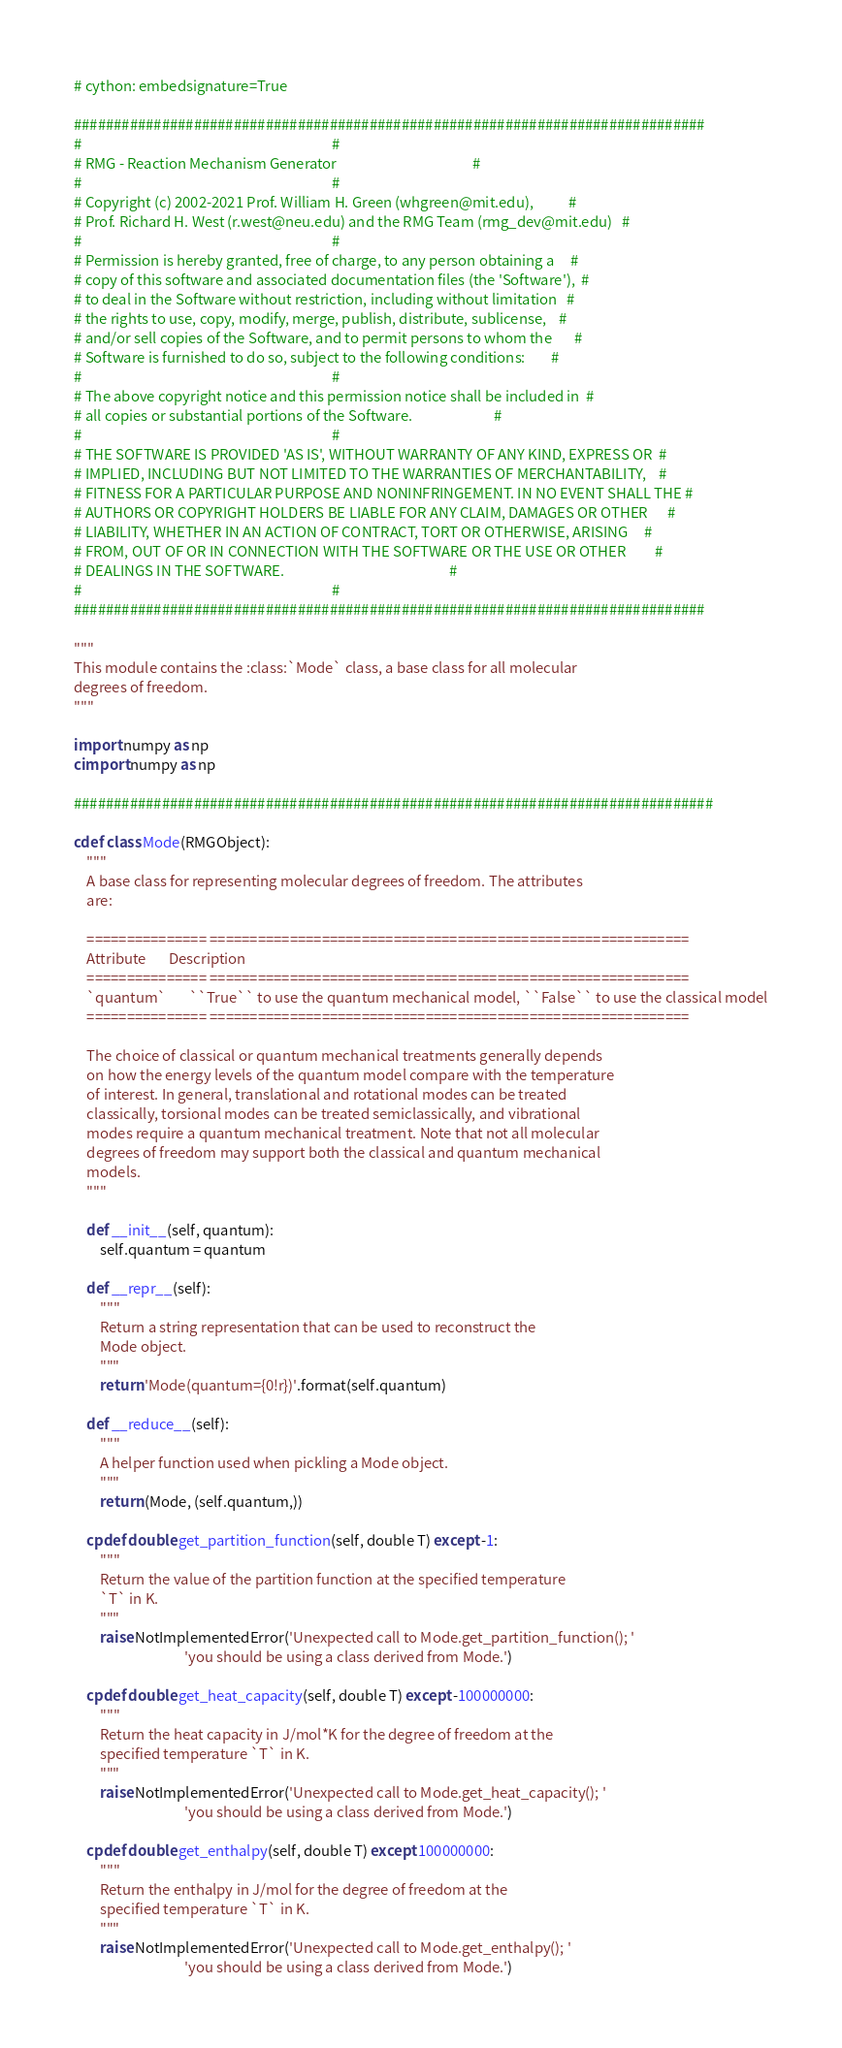Convert code to text. <code><loc_0><loc_0><loc_500><loc_500><_Cython_># cython: embedsignature=True

###############################################################################
#                                                                             #
# RMG - Reaction Mechanism Generator                                          #
#                                                                             #
# Copyright (c) 2002-2021 Prof. William H. Green (whgreen@mit.edu),           #
# Prof. Richard H. West (r.west@neu.edu) and the RMG Team (rmg_dev@mit.edu)   #
#                                                                             #
# Permission is hereby granted, free of charge, to any person obtaining a     #
# copy of this software and associated documentation files (the 'Software'),  #
# to deal in the Software without restriction, including without limitation   #
# the rights to use, copy, modify, merge, publish, distribute, sublicense,    #
# and/or sell copies of the Software, and to permit persons to whom the       #
# Software is furnished to do so, subject to the following conditions:        #
#                                                                             #
# The above copyright notice and this permission notice shall be included in  #
# all copies or substantial portions of the Software.                         #
#                                                                             #
# THE SOFTWARE IS PROVIDED 'AS IS', WITHOUT WARRANTY OF ANY KIND, EXPRESS OR  #
# IMPLIED, INCLUDING BUT NOT LIMITED TO THE WARRANTIES OF MERCHANTABILITY,    #
# FITNESS FOR A PARTICULAR PURPOSE AND NONINFRINGEMENT. IN NO EVENT SHALL THE #
# AUTHORS OR COPYRIGHT HOLDERS BE LIABLE FOR ANY CLAIM, DAMAGES OR OTHER      #
# LIABILITY, WHETHER IN AN ACTION OF CONTRACT, TORT OR OTHERWISE, ARISING     #
# FROM, OUT OF OR IN CONNECTION WITH THE SOFTWARE OR THE USE OR OTHER         #
# DEALINGS IN THE SOFTWARE.                                                   #
#                                                                             #
###############################################################################

"""
This module contains the :class:`Mode` class, a base class for all molecular
degrees of freedom.
"""

import numpy as np
cimport numpy as np

################################################################################

cdef class Mode(RMGObject):
    """
    A base class for representing molecular degrees of freedom. The attributes
    are:
    
    =============== ============================================================
    Attribute       Description
    =============== ============================================================
    `quantum`       ``True`` to use the quantum mechanical model, ``False`` to use the classical model
    =============== ============================================================
    
    The choice of classical or quantum mechanical treatments generally depends
    on how the energy levels of the quantum model compare with the temperature
    of interest. In general, translational and rotational modes can be treated
    classically, torsional modes can be treated semiclassically, and vibrational
    modes require a quantum mechanical treatment. Note that not all molecular
    degrees of freedom may support both the classical and quantum mechanical
    models.
    """

    def __init__(self, quantum):
        self.quantum = quantum

    def __repr__(self):
        """
        Return a string representation that can be used to reconstruct the
        Mode object.
        """
        return 'Mode(quantum={0!r})'.format(self.quantum)

    def __reduce__(self):
        """
        A helper function used when pickling a Mode object.
        """
        return (Mode, (self.quantum,))

    cpdef double get_partition_function(self, double T) except -1:
        """
        Return the value of the partition function at the specified temperature
        `T` in K.
        """
        raise NotImplementedError('Unexpected call to Mode.get_partition_function(); '
                                  'you should be using a class derived from Mode.')

    cpdef double get_heat_capacity(self, double T) except -100000000:
        """
        Return the heat capacity in J/mol*K for the degree of freedom at the
        specified temperature `T` in K.
        """
        raise NotImplementedError('Unexpected call to Mode.get_heat_capacity(); '
                                  'you should be using a class derived from Mode.')

    cpdef double get_enthalpy(self, double T) except 100000000:
        """
        Return the enthalpy in J/mol for the degree of freedom at the
        specified temperature `T` in K.
        """
        raise NotImplementedError('Unexpected call to Mode.get_enthalpy(); '
                                  'you should be using a class derived from Mode.')
</code> 